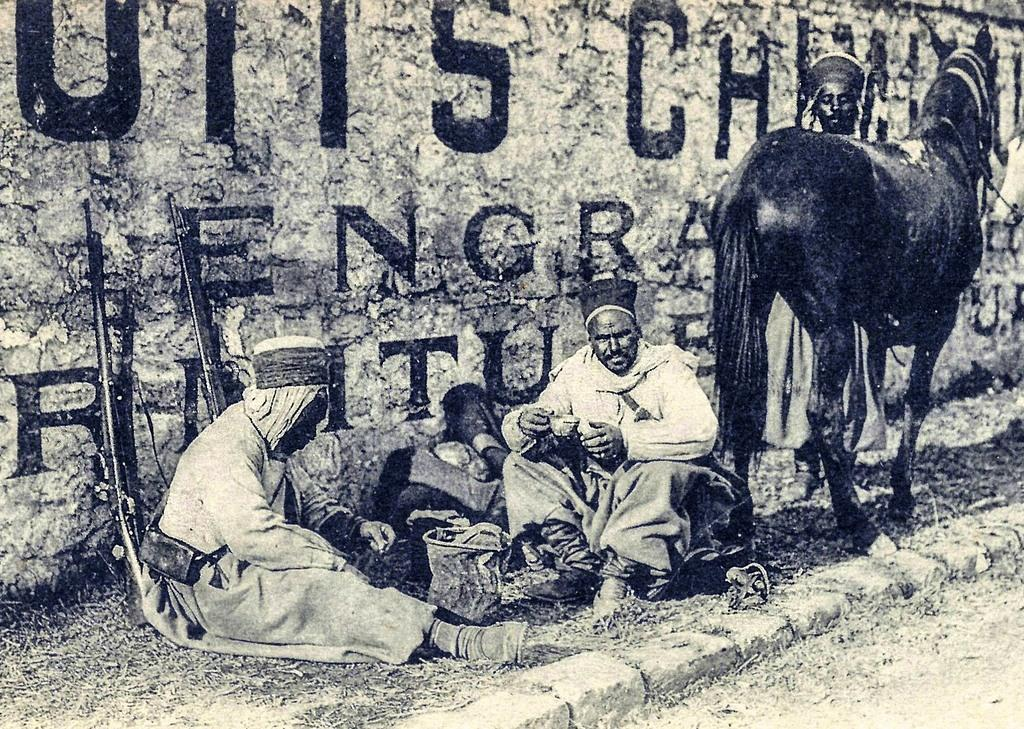What type of structure can be seen in the image? There is a wall in the image. What animal is present in the image? There is a black color horse in the image. Are there any human beings in the image? Yes, there are people present in the image. What type of grape is being used to create harmony in the image? There is no grape present in the image, nor is there any indication of harmony being created. 